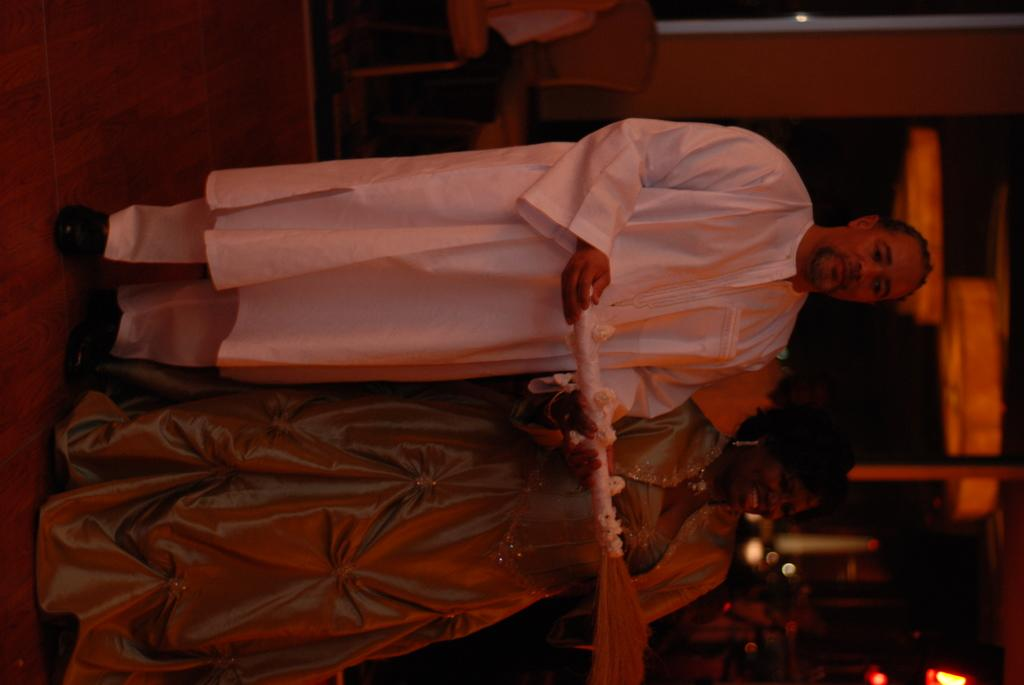What is the gender of the person in the image? There is a man in the image. What is the man doing in the image? The man is standing. What is the man wearing in the image? The man is wearing a white dress. Is there anyone else in the image besides the man? Yes, there is a woman in the image. What is the woman doing in the image? The woman is standing beside the man. What are the man and the woman holding in the image? Both the man and the woman are holding an object. How many beds can be seen in the image? There are no beds present in the image. What type of bead is being used to decorate the ice in the image? There is no ice or bead present in the image. 